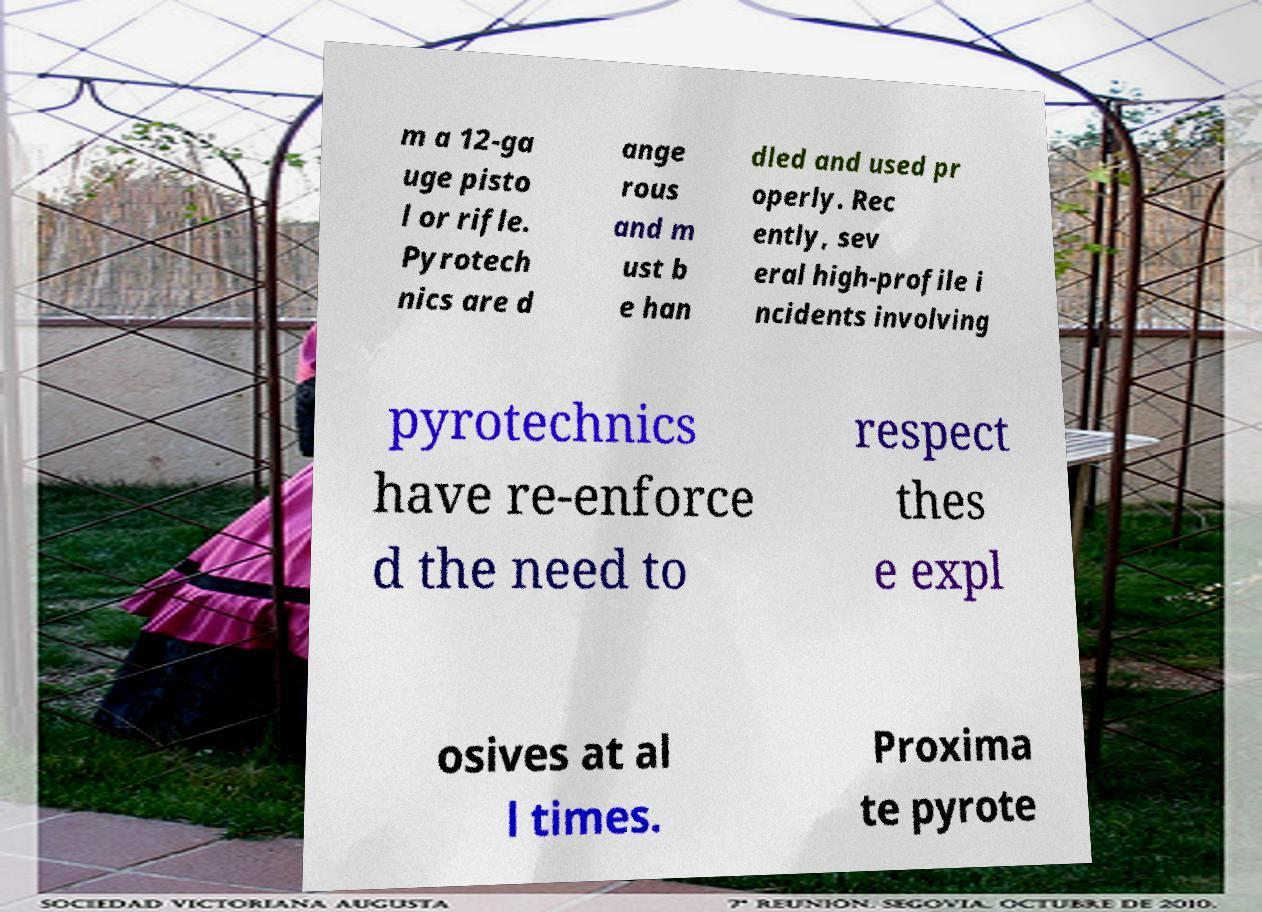Can you accurately transcribe the text from the provided image for me? m a 12-ga uge pisto l or rifle. Pyrotech nics are d ange rous and m ust b e han dled and used pr operly. Rec ently, sev eral high-profile i ncidents involving pyrotechnics have re-enforce d the need to respect thes e expl osives at al l times. Proxima te pyrote 